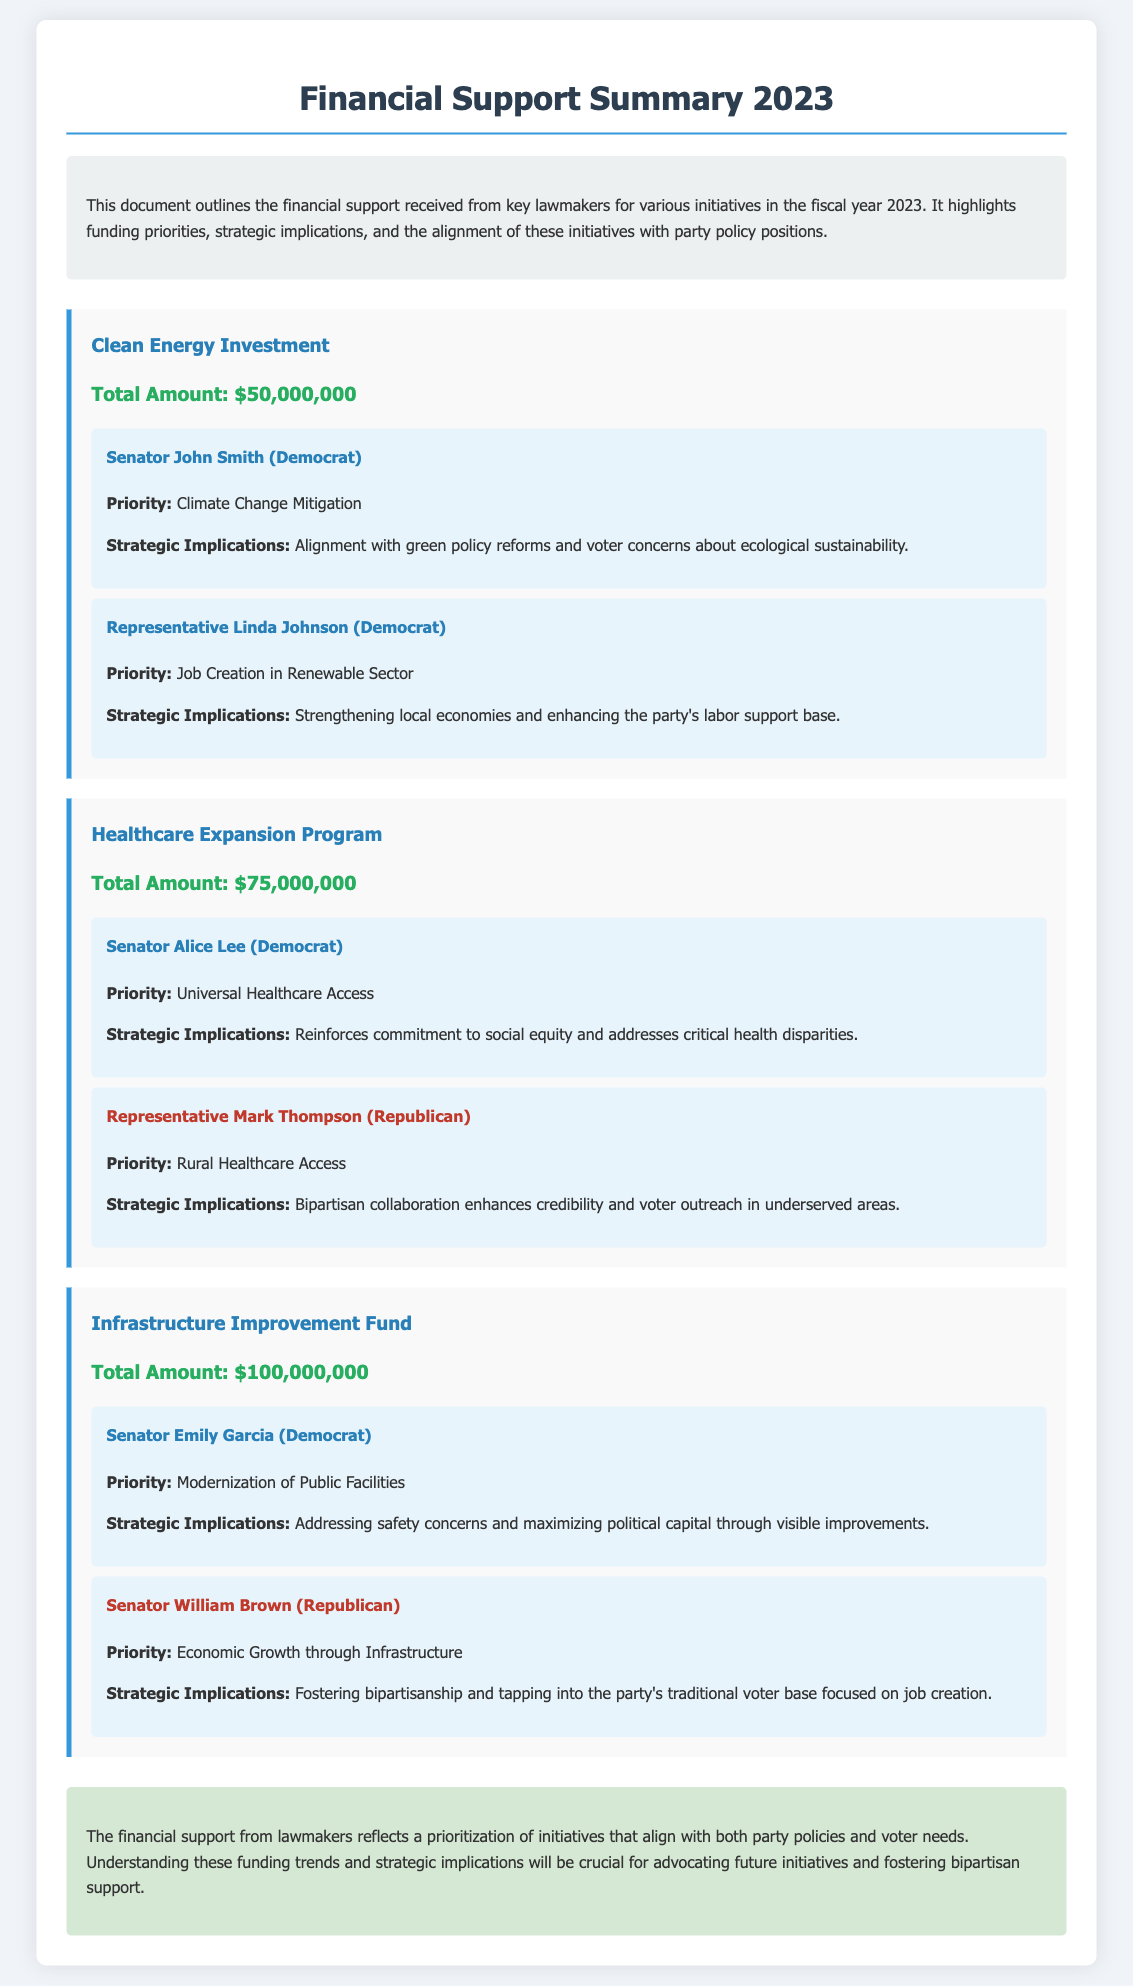What is the total amount for the Clean Energy Investment initiative? The total amount specifically allocated for the Clean Energy Investment initiative, as stated in the document, is $50,000,000.
Answer: $50,000,000 Which lawmaker supports the Healthcare Expansion Program focused on Universal Healthcare Access? The document identifies Senator Alice Lee as the lawmaker who supports the Healthcare Expansion Program with a focus on Universal Healthcare Access.
Answer: Senator Alice Lee What is the priority for Representative Mark Thompson regarding the Healthcare Expansion Program? According to the document, Representative Mark Thompson's priority within the Healthcare Expansion Program is Rural Healthcare Access.
Answer: Rural Healthcare Access How much funding is allocated to the Infrastructure Improvement Fund? The document specifies that the Infrastructure Improvement Fund has a total allocation of $100,000,000.
Answer: $100,000,000 What strategic implication is associated with the Clean Energy Investment initiative? The Clean Energy Investment initiative's strategic implication is its alignment with green policy reforms and voter concerns about ecological sustainability.
Answer: Alignment with green policy reforms Who is the Democratic Senator that supports modernizing public facilities? The document states that Senator Emily Garcia is the Democratic Senator advocating for the modernization of public facilities within the Infrastructure Improvement Fund.
Answer: Senator Emily Garcia What does the financial support summary reflect about lawmakers' priorities? The summary indicates that the financial support reflects a prioritization of initiatives that align with both party policies and voter needs.
Answer: Prioritization of initiatives What is the total amount for the Healthcare Expansion Program? The document clearly states that the total amount received for the Healthcare Expansion Program is $75,000,000.
Answer: $75,000,000 